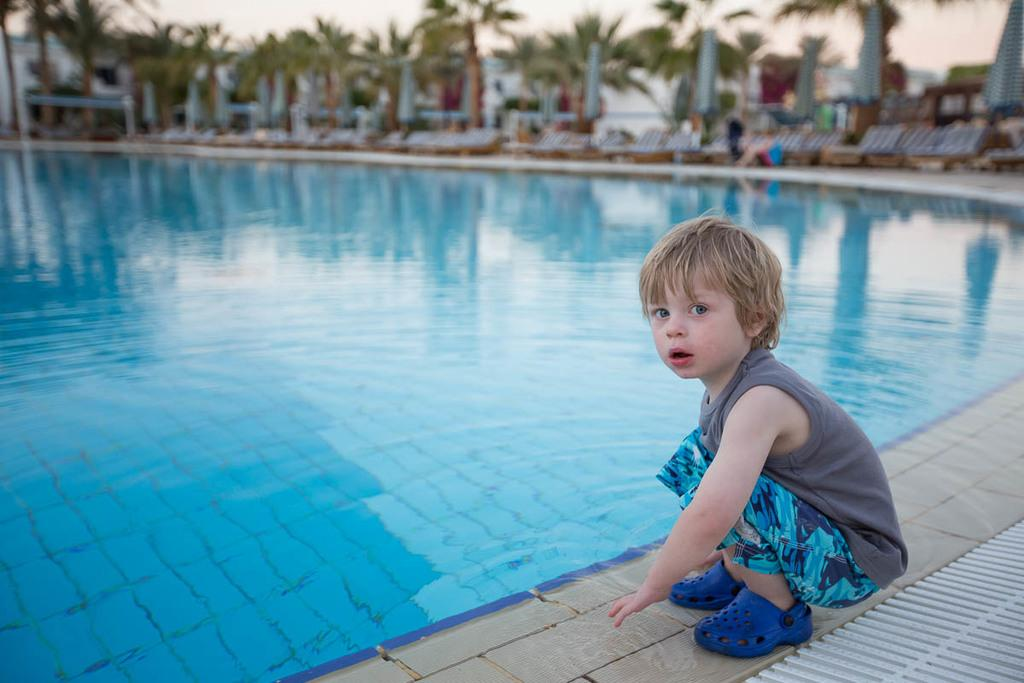What position is the boy in the image? There is a boy sitting in a squat position in the image. What body of water is present in the image? There is a pool in the image. What type of outdoor furniture can be seen in the image? There are beach chairs in the image. What type of vegetation is visible in the image? There are trees visible in the image. What type of feast is being prepared in the image? There is no feast being prepared in the image. Can you see a plane flying in the sky in the image? There is no plane visible in the image. Are there any stockings visible on the boy in the image? There is no mention of stockings in the image, and the boy's attire is not described. 